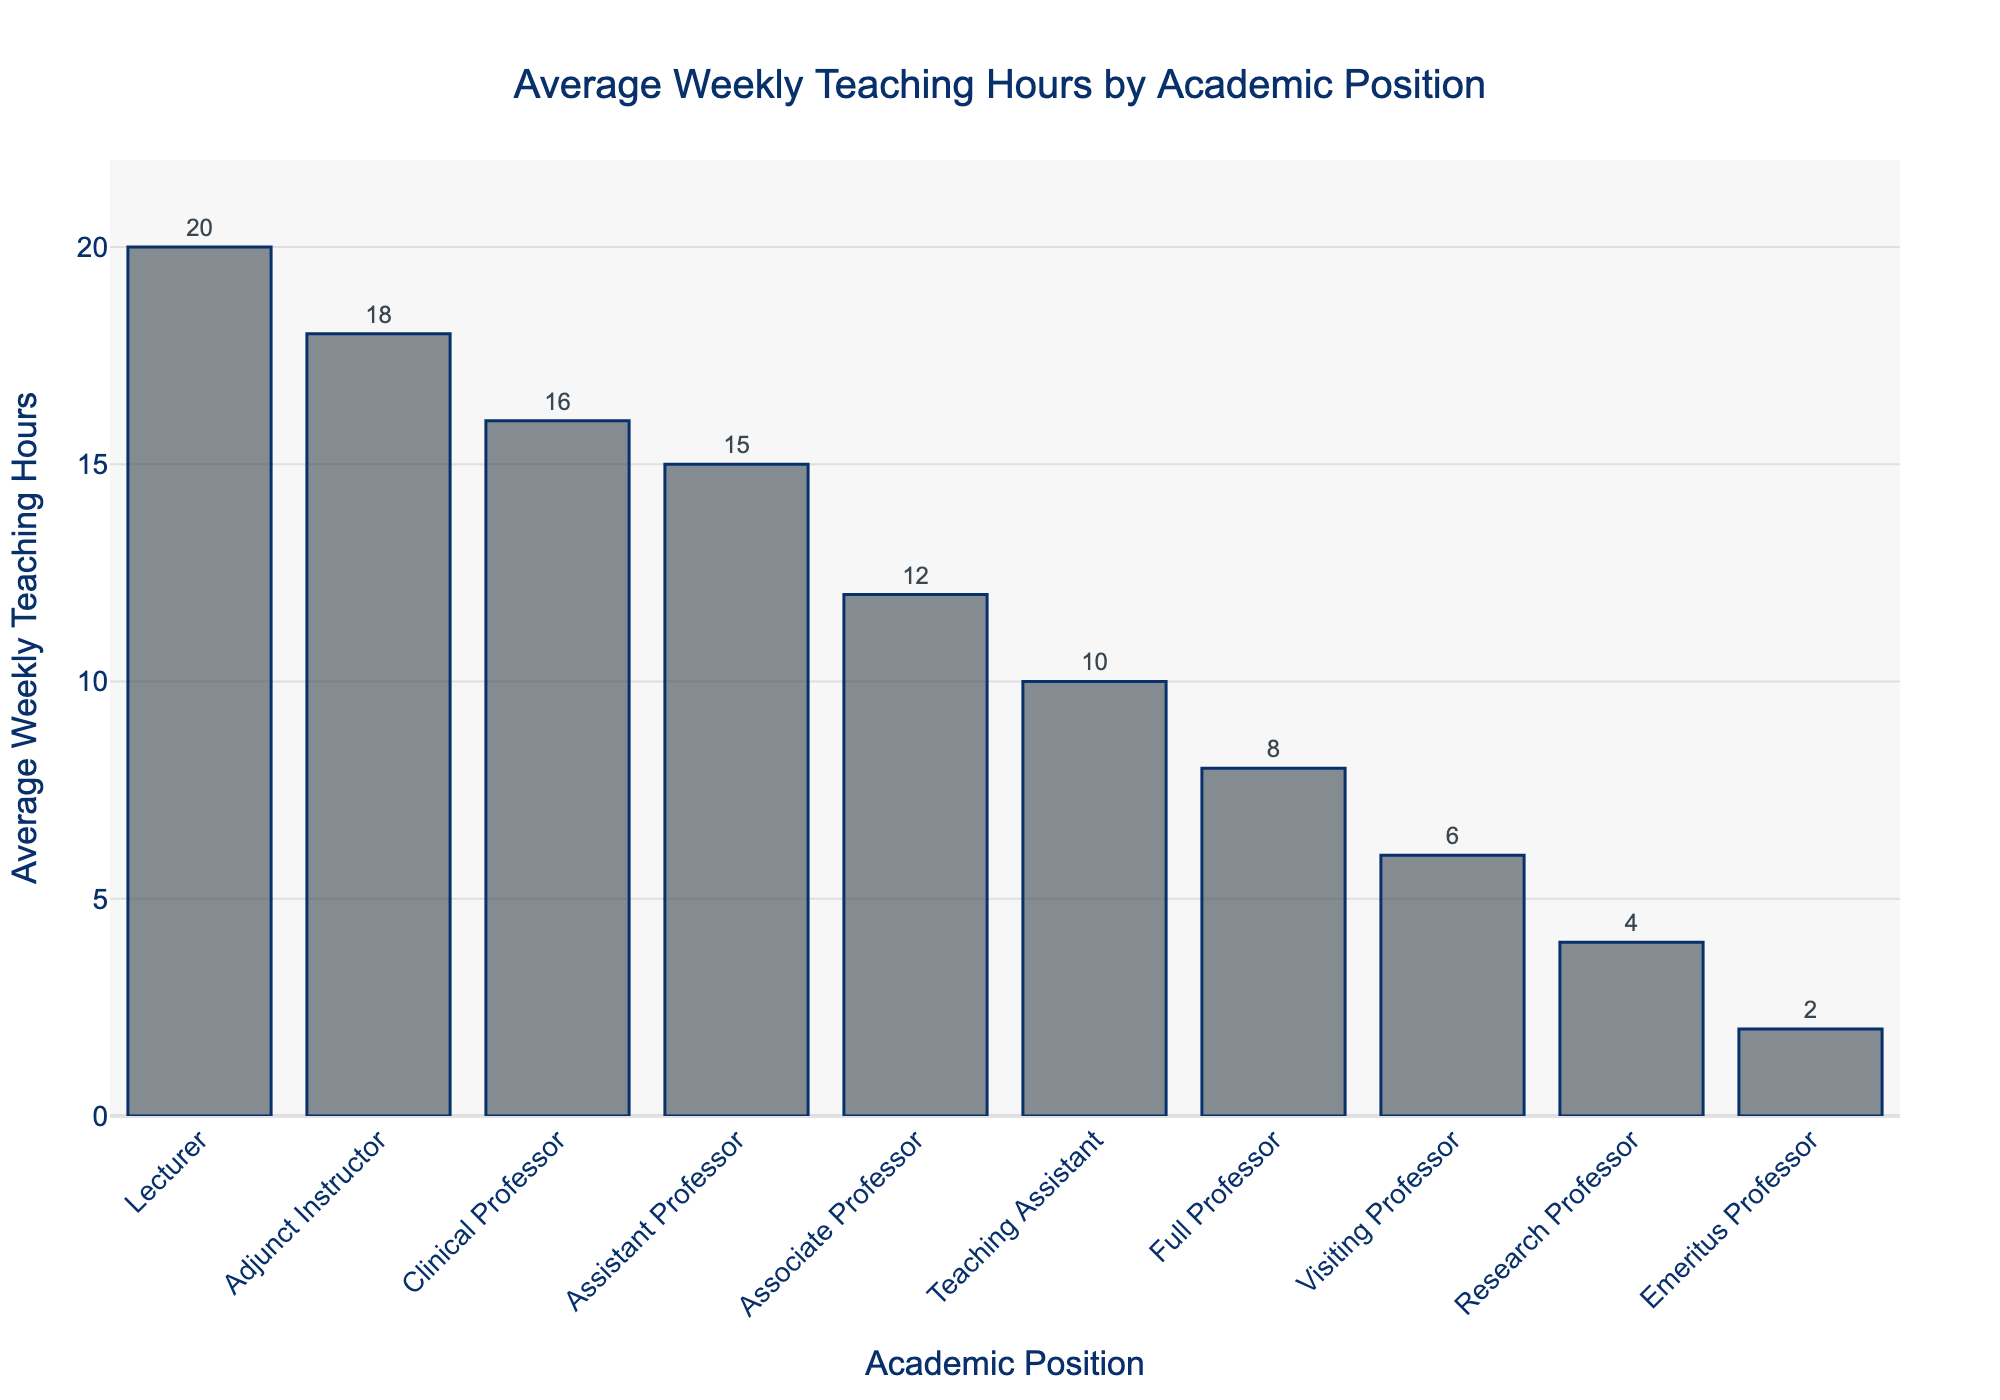Which academic position has the highest average weekly teaching hours? By looking at the height of the bars, the Lecturer position has the highest bar indicating the most hours.
Answer: Lecturer Which academic position has the lowest average weekly teaching hours? The Emeritus Professor has the shortest bar in the chart, indicating the least hours.
Answer: Emeritus Professor How many more weekly teaching hours does an Adjunct Instructor have compared to a Full Professor? The bar for Adjunct Instructor is at 18 hours and for Full Professor it is at 8 hours. The difference is 18 - 8 = 10 hours.
Answer: 10 hours What is the difference in average weekly teaching hours between a Teaching Assistant and a Clinical Professor? The bar for Teaching Assistant is at 10 hours and for Clinical Professor it is at 16 hours. The difference is 16 - 10 = 6 hours.
Answer: 6 hours What is the median average weekly teaching hours among all academic positions? To find the median, list the values in order: 2, 4, 6, 8, 10, 12, 15, 16, 18, 20. The median is the average of the 5th and 6th values: (10 + 12) / 2 = 11.
Answer: 11 hours Do Full Professors teach more or less than Associate Professors? By comparing the heights of the two bars, Full Professors (8 hours) teach less than Associate Professors (12 hours).
Answer: Less Are there more academic positions with teaching hours greater than 10 or less than 10? Positions with greater than 10 hours: Associate Professor, Assistant Professor, Adjunct Instructor, Lecturer, Clinical Professor (5 positions). Positions with less than 10 hours: Visiting Professor, Research Professor, Emeritus Professor (3 positions).
Answer: Greater than 10 What is the total average weekly teaching hours for Full Professor, Associate Professor, and Assistant Professor combined? Summing the values: 8 (Full Professor) + 12 (Associate Professor) + 15 (Assistant Professor) = 35 hours.
Answer: 35 hours Which academic position has exactly twice the weekly teaching hours of the Emeritus Professor? The Emeritus Professor has 2 hours, so twice this is 2 * 2 = 4 hours, which is the Research Professor.
Answer: Research Professor 